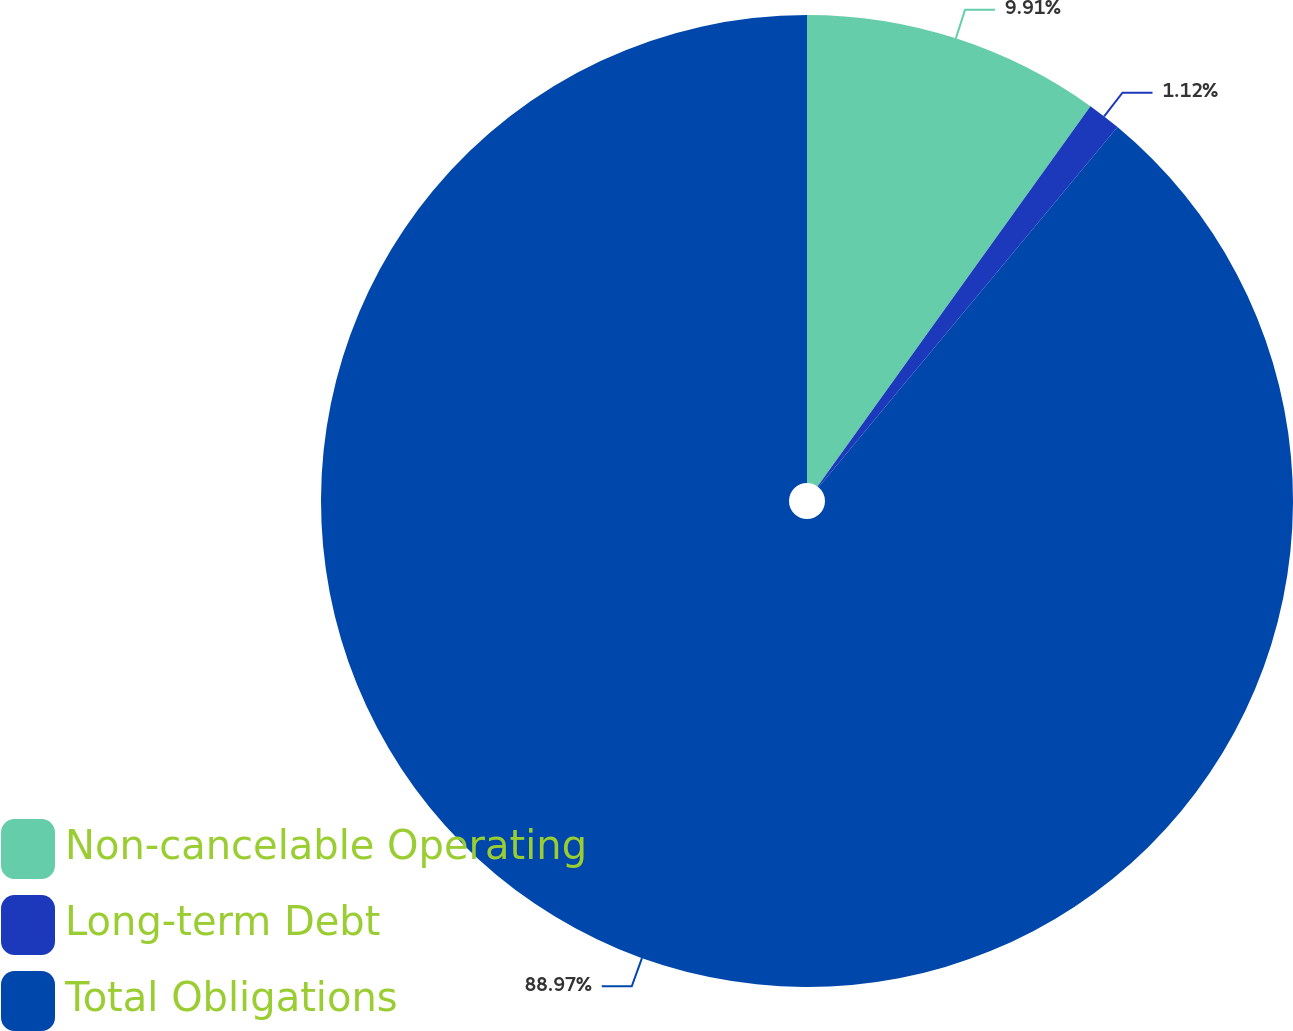Convert chart. <chart><loc_0><loc_0><loc_500><loc_500><pie_chart><fcel>Non-cancelable Operating<fcel>Long-term Debt<fcel>Total Obligations<nl><fcel>9.91%<fcel>1.12%<fcel>88.97%<nl></chart> 